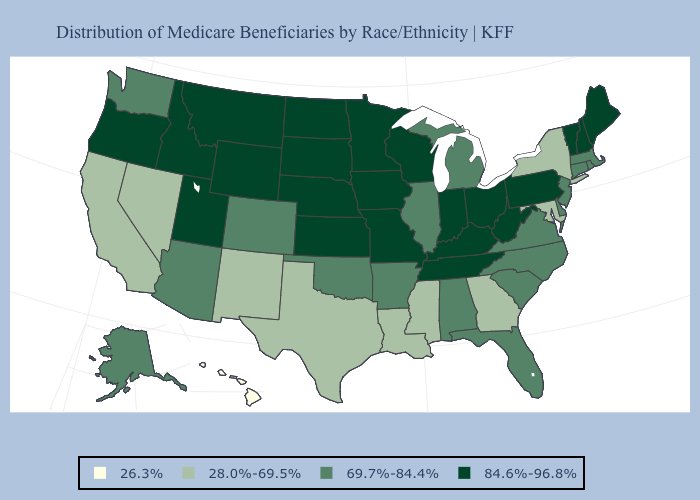Name the states that have a value in the range 26.3%?
Keep it brief. Hawaii. Which states have the lowest value in the MidWest?
Be succinct. Illinois, Michigan. Among the states that border Washington , which have the lowest value?
Answer briefly. Idaho, Oregon. Does Vermont have the lowest value in the Northeast?
Write a very short answer. No. What is the value of New Jersey?
Be succinct. 69.7%-84.4%. Name the states that have a value in the range 28.0%-69.5%?
Write a very short answer. California, Georgia, Louisiana, Maryland, Mississippi, Nevada, New Mexico, New York, Texas. Which states have the highest value in the USA?
Write a very short answer. Idaho, Indiana, Iowa, Kansas, Kentucky, Maine, Minnesota, Missouri, Montana, Nebraska, New Hampshire, North Dakota, Ohio, Oregon, Pennsylvania, South Dakota, Tennessee, Utah, Vermont, West Virginia, Wisconsin, Wyoming. What is the lowest value in states that border Pennsylvania?
Keep it brief. 28.0%-69.5%. What is the value of South Dakota?
Quick response, please. 84.6%-96.8%. What is the highest value in the USA?
Answer briefly. 84.6%-96.8%. What is the value of Michigan?
Short answer required. 69.7%-84.4%. What is the value of Texas?
Give a very brief answer. 28.0%-69.5%. Name the states that have a value in the range 28.0%-69.5%?
Be succinct. California, Georgia, Louisiana, Maryland, Mississippi, Nevada, New Mexico, New York, Texas. Is the legend a continuous bar?
Quick response, please. No. Name the states that have a value in the range 26.3%?
Be succinct. Hawaii. 